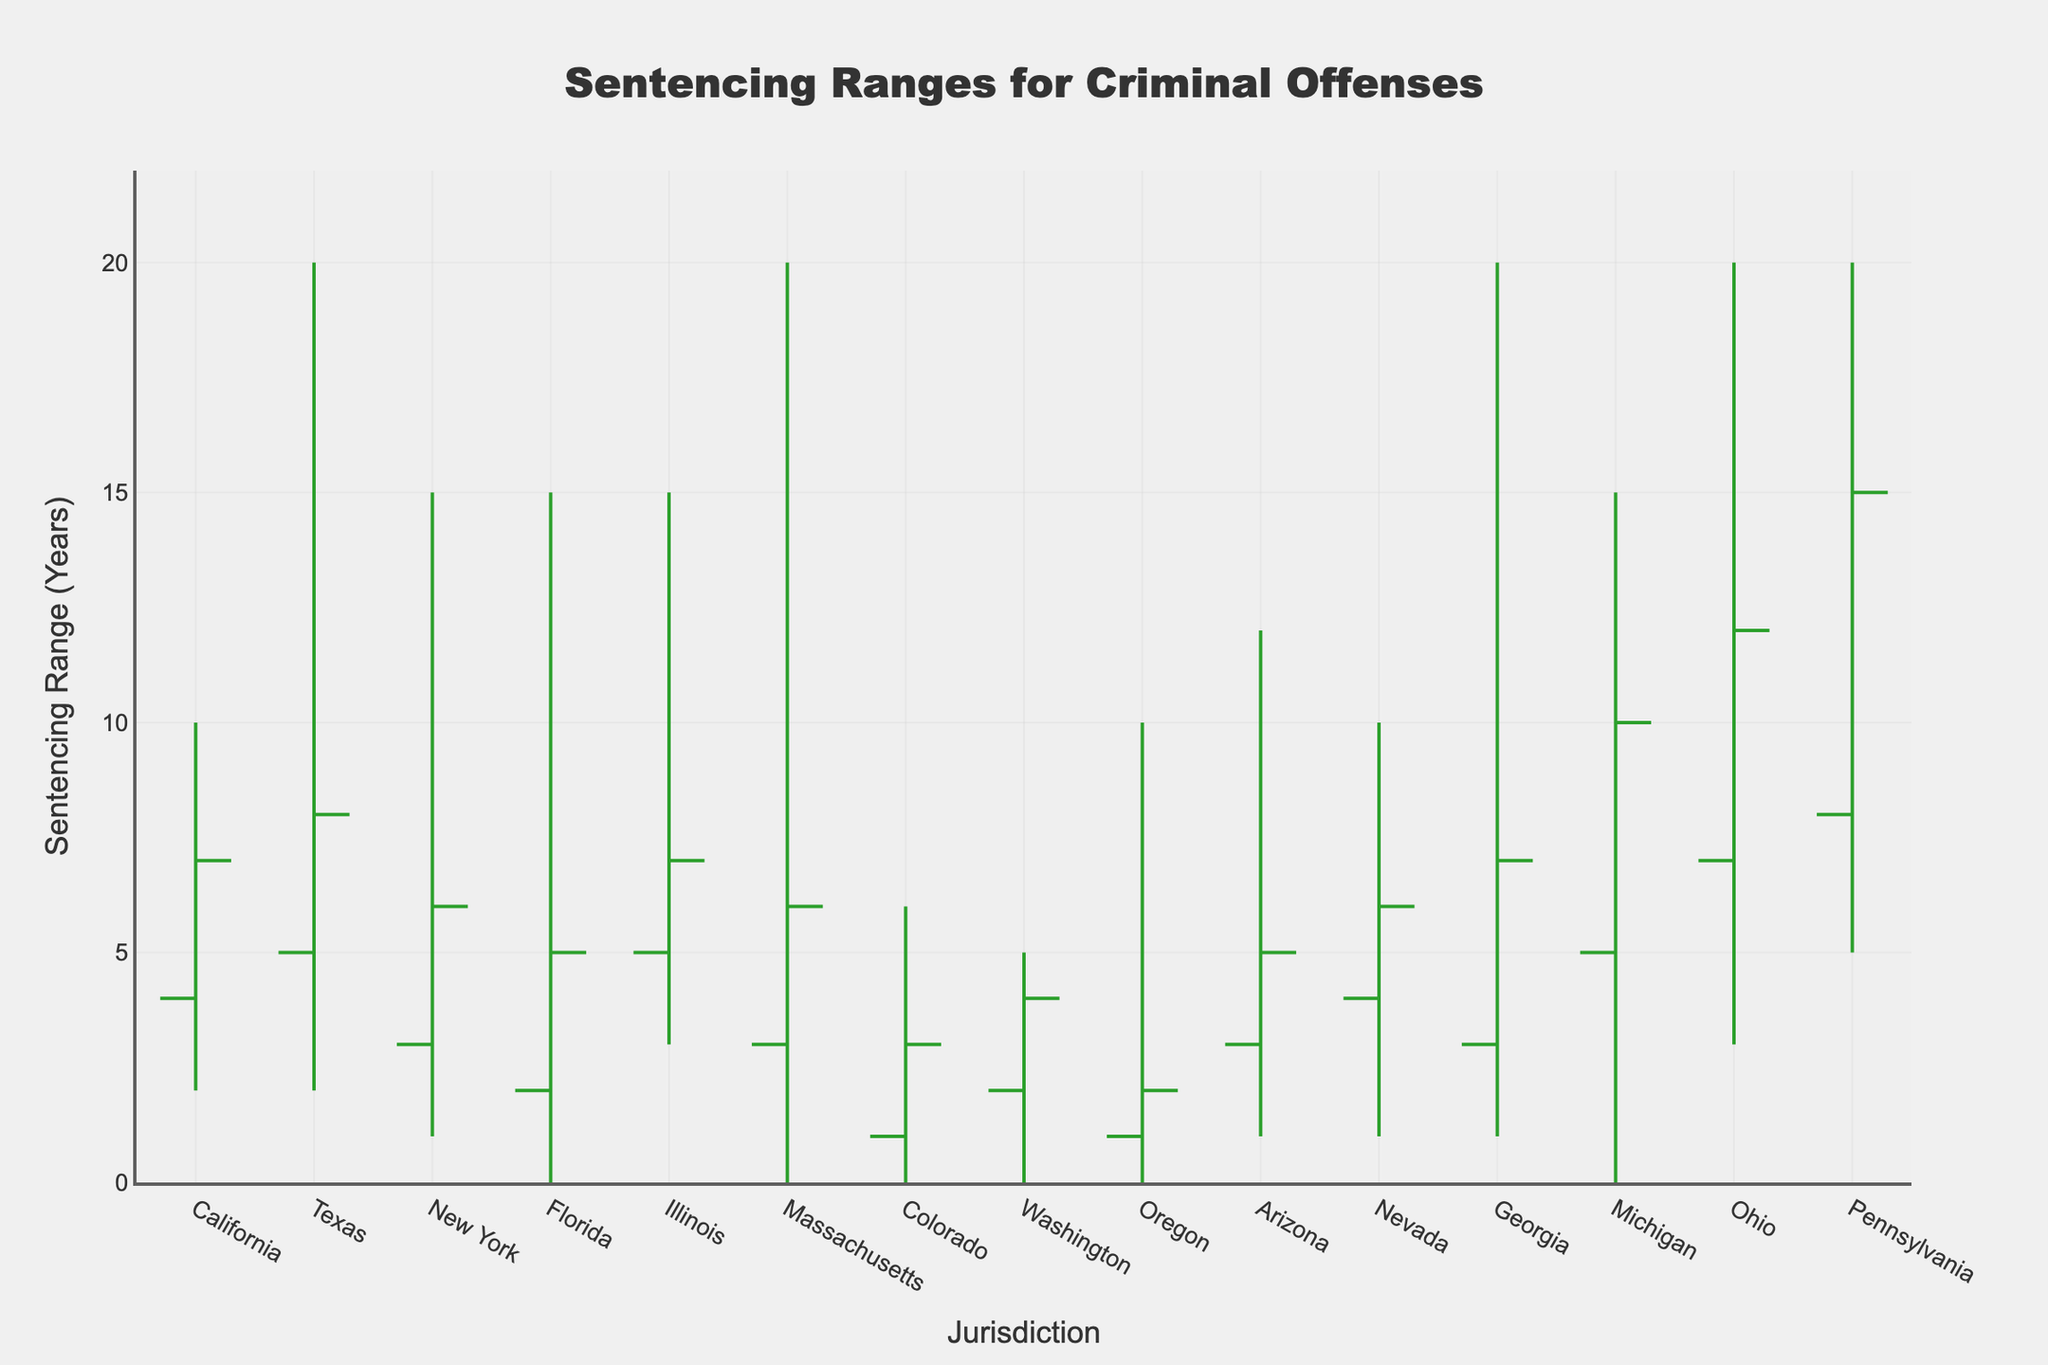What's the title of the figure? The title of the figure is typically displayed at the top of the chart. In this figure, it reads 'Sentencing Ranges for Criminal Offenses'.
Answer: Sentencing Ranges for Criminal Offenses What is the maximum sentence for Manslaughter in Ohio? The maximum sentence for Manslaughter in Ohio can be directly observed on the y-axis corresponding to the bar for Ohio.
Answer: 20 years Which jurisdiction has the highest maximum sentence for Aggravated Assault? By examining the maximum values on the y-axis for jurisdictions associated with Aggravated Assault, we observe that Texas has the highest maximum sentence of 20 years.
Answer: Texas What range is used to display sentencing ranges on the y-axis? The y-axis range can be deduced from the highest value indicated, which extends just beyond the greatest maximum sentence. The figure's y-axis extends up to slightly above 20 years.
Answer: Up to 22 years Which offense shows the greatest variation in sentencing within California? To determine the greatest variation, subtract the minimum value from the maximum value for each offense under California. For Aggravated Assault, it ranges from 2 to 10 years, making the variation 8 years.
Answer: Aggravated Assault How does the opening sentence for Drug Possession in Washington compare to Oregon? Observe the opening values for Drug Posession in both Washington and Oregon. Washington's opening sentence is 2 years, whereas Oregon's opening sentence is 1 year. 2 years is greater than 1 year.
Answer: Washington's is higher For which offense is the sentencing range most consistent across all jurisdictions? Consistency in sentencing ranges means the smallest difference between the minimum and maximum values across all jurisdictions for a specific offense. Drug Possession shows fairly low variability: 0-6 years in Colorado, 0-5 in Washington, and 0-10 in Oregon. However, Grand Theft Auto shows more variability, so Drug Possession is the most consistent.
Answer: Drug Possession What is the lowest minimum sentencing value across all jurisdictions and offenses? Find the smallest value in the 'Minimum' column across all rows. The minimum value here is 0 years, which appears in several jurisdictions and offenses.
Answer: 0 years Compare the closing sentencing values for Burglary in Massachusetts and Illinois. Which is higher? Look at the closing values on the y-axis for both Illinois and Massachusetts under Burglary. The closing value for Massachusetts is 6 years, while for Illinois it is 7 years, making Illinois' higher.
Answer: Illinois Which offense in California has the closing sentence higher than its opening value? Compare the opening and closing values for the offense in the jurisdiction of California. For Aggravated Assault, the opening value is 4 and the closing value is 7. Since 7 is greater than 4, this offense meets the criteria.
Answer: Aggravated Assault 